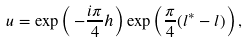<formula> <loc_0><loc_0><loc_500><loc_500>u = \exp \left ( \, - \frac { i \pi } { 4 } h \right ) \exp \left ( \frac { \pi } { 4 } ( l ^ { * } - l ) \right ) ,</formula> 